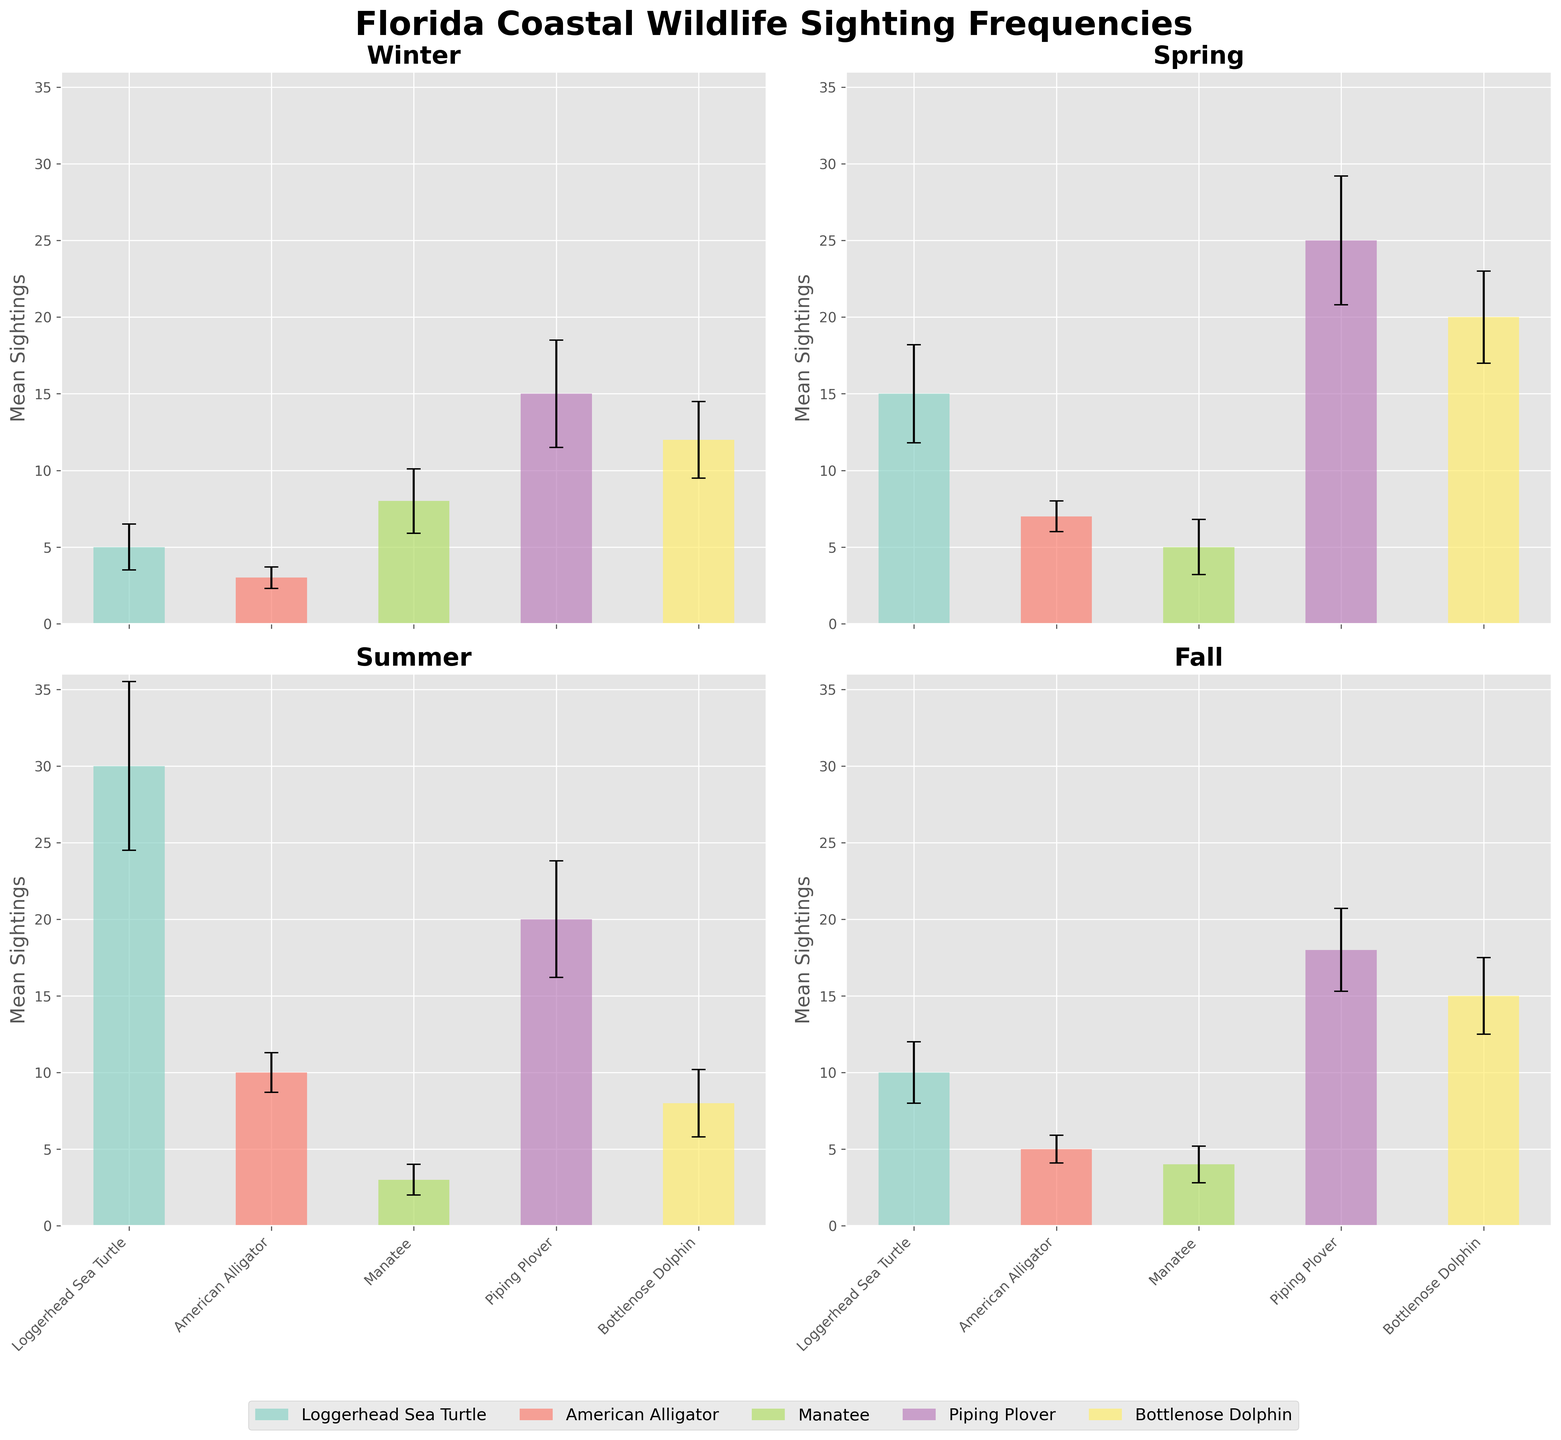What's the title of the figure? The title is displayed at the top of the figure, usually in a larger and bold font to make it stand out.
Answer: Florida Coastal Wildlife Sighting Frequencies During which season are Loggerhead Sea Turtle sightings the highest? Look at the height of the bars for Loggerhead Sea Turtle sightings across the four subplots. Identify the tallest bar.
Answer: Summer How many animals are tracked in this figure? Each subplot represents different animals within each season. Count the unique animal types listed along the x-axis.
Answer: 5 Which season has the highest mean sighting for Bottlenose Dolphins? Look at the mean sightings bars for Bottlenose Dolphins across different seasons and identify the tallest one.
Answer: Spring What's the mean sighting of Manatees in Winter? Find the bar corresponding to Manatees in the Winter subplot and read the mean value.
Answer: 8 Which animal has the smallest standard deviation in Summer? Locate the error bars in the Summer subplot and find the one with the smallest length, indicating the smallest standard deviation.
Answer: Manatee On average, how many American Alligator sightings are there in Spring and Fall combined? First, find the mean sightings of American Alligator for both Spring and Fall. Sum these means.
Answer: (7 + 5) = 12 Compare the sightings of Piping Plovers in Winter and Summer. Which season has more sightings and by how much? Identify the heights of the Piping Plover bars in Winter and Summer, then calculate the difference.
Answer: Summer has 5 more sightings (20 - 15) What is the overall trend in Loggerhead Sea Turtle sightings from Winter to Fall? Observe the heights of the Loggerhead Sea Turtle bars across all seasons and describe whether they are increasing, decreasing, or showing another pattern.
Answer: Increasing, peaking in Summer, then decreasing During which season are Manatees least frequently sighted? Find the shortest bar for Manatees across the four subplots.
Answer: Summer 